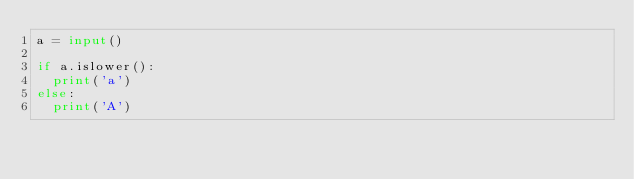Convert code to text. <code><loc_0><loc_0><loc_500><loc_500><_Python_>a = input()

if a.islower():
  print('a')
else:
  print('A')</code> 